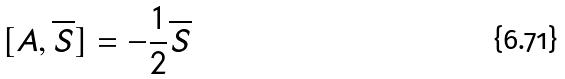Convert formula to latex. <formula><loc_0><loc_0><loc_500><loc_500>[ A , \overline { S } ] = - \frac { 1 } { 2 } \overline { S }</formula> 